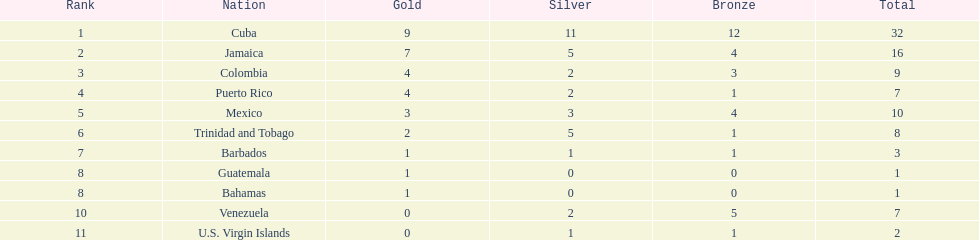Which team had four gold models and one bronze medal? Puerto Rico. 